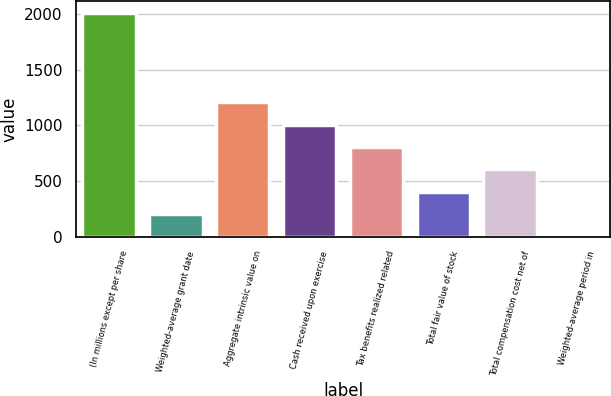<chart> <loc_0><loc_0><loc_500><loc_500><bar_chart><fcel>(In millions except per share<fcel>Weighted-average grant date<fcel>Aggregate intrinsic value on<fcel>Cash received upon exercise<fcel>Tax benefits realized related<fcel>Total fair value of stock<fcel>Total compensation cost net of<fcel>Weighted-average period in<nl><fcel>2013<fcel>202.2<fcel>1208.2<fcel>1007<fcel>805.8<fcel>403.4<fcel>604.6<fcel>1<nl></chart> 